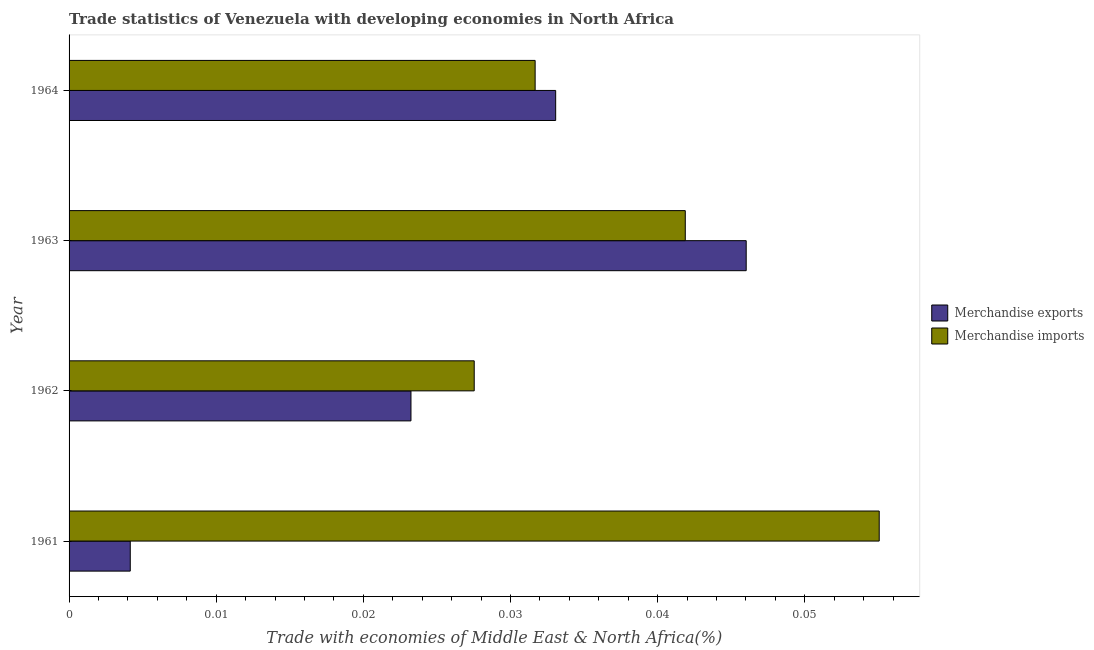How many groups of bars are there?
Make the answer very short. 4. Are the number of bars per tick equal to the number of legend labels?
Give a very brief answer. Yes. Are the number of bars on each tick of the Y-axis equal?
Your answer should be very brief. Yes. How many bars are there on the 2nd tick from the bottom?
Your answer should be very brief. 2. What is the label of the 2nd group of bars from the top?
Provide a short and direct response. 1963. What is the merchandise imports in 1963?
Ensure brevity in your answer.  0.04. Across all years, what is the maximum merchandise exports?
Ensure brevity in your answer.  0.05. Across all years, what is the minimum merchandise imports?
Your answer should be very brief. 0.03. In which year was the merchandise exports maximum?
Your response must be concise. 1963. What is the total merchandise imports in the graph?
Give a very brief answer. 0.16. What is the difference between the merchandise imports in 1962 and that in 1964?
Provide a succinct answer. -0. What is the difference between the merchandise exports in 1962 and the merchandise imports in 1961?
Make the answer very short. -0.03. What is the average merchandise imports per year?
Give a very brief answer. 0.04. In the year 1963, what is the difference between the merchandise imports and merchandise exports?
Your response must be concise. -0. In how many years, is the merchandise imports greater than 0.02 %?
Make the answer very short. 4. What is the ratio of the merchandise exports in 1961 to that in 1962?
Offer a terse response. 0.18. Is the merchandise imports in 1961 less than that in 1963?
Offer a terse response. No. Is the difference between the merchandise exports in 1962 and 1963 greater than the difference between the merchandise imports in 1962 and 1963?
Ensure brevity in your answer.  No. What is the difference between the highest and the second highest merchandise exports?
Your response must be concise. 0.01. In how many years, is the merchandise exports greater than the average merchandise exports taken over all years?
Make the answer very short. 2. How many bars are there?
Offer a terse response. 8. Are all the bars in the graph horizontal?
Offer a very short reply. Yes. Are the values on the major ticks of X-axis written in scientific E-notation?
Your answer should be compact. No. Does the graph contain any zero values?
Make the answer very short. No. How many legend labels are there?
Offer a terse response. 2. What is the title of the graph?
Provide a short and direct response. Trade statistics of Venezuela with developing economies in North Africa. Does "Resident" appear as one of the legend labels in the graph?
Your answer should be very brief. No. What is the label or title of the X-axis?
Your answer should be very brief. Trade with economies of Middle East & North Africa(%). What is the Trade with economies of Middle East & North Africa(%) in Merchandise exports in 1961?
Offer a very short reply. 0. What is the Trade with economies of Middle East & North Africa(%) of Merchandise imports in 1961?
Your response must be concise. 0.06. What is the Trade with economies of Middle East & North Africa(%) of Merchandise exports in 1962?
Provide a succinct answer. 0.02. What is the Trade with economies of Middle East & North Africa(%) in Merchandise imports in 1962?
Your answer should be very brief. 0.03. What is the Trade with economies of Middle East & North Africa(%) in Merchandise exports in 1963?
Keep it short and to the point. 0.05. What is the Trade with economies of Middle East & North Africa(%) of Merchandise imports in 1963?
Ensure brevity in your answer.  0.04. What is the Trade with economies of Middle East & North Africa(%) in Merchandise exports in 1964?
Make the answer very short. 0.03. What is the Trade with economies of Middle East & North Africa(%) in Merchandise imports in 1964?
Provide a succinct answer. 0.03. Across all years, what is the maximum Trade with economies of Middle East & North Africa(%) of Merchandise exports?
Your response must be concise. 0.05. Across all years, what is the maximum Trade with economies of Middle East & North Africa(%) of Merchandise imports?
Your response must be concise. 0.06. Across all years, what is the minimum Trade with economies of Middle East & North Africa(%) in Merchandise exports?
Make the answer very short. 0. Across all years, what is the minimum Trade with economies of Middle East & North Africa(%) in Merchandise imports?
Offer a very short reply. 0.03. What is the total Trade with economies of Middle East & North Africa(%) in Merchandise exports in the graph?
Your answer should be very brief. 0.11. What is the total Trade with economies of Middle East & North Africa(%) in Merchandise imports in the graph?
Give a very brief answer. 0.16. What is the difference between the Trade with economies of Middle East & North Africa(%) in Merchandise exports in 1961 and that in 1962?
Make the answer very short. -0.02. What is the difference between the Trade with economies of Middle East & North Africa(%) in Merchandise imports in 1961 and that in 1962?
Give a very brief answer. 0.03. What is the difference between the Trade with economies of Middle East & North Africa(%) of Merchandise exports in 1961 and that in 1963?
Your answer should be compact. -0.04. What is the difference between the Trade with economies of Middle East & North Africa(%) of Merchandise imports in 1961 and that in 1963?
Ensure brevity in your answer.  0.01. What is the difference between the Trade with economies of Middle East & North Africa(%) of Merchandise exports in 1961 and that in 1964?
Your answer should be compact. -0.03. What is the difference between the Trade with economies of Middle East & North Africa(%) of Merchandise imports in 1961 and that in 1964?
Your answer should be compact. 0.02. What is the difference between the Trade with economies of Middle East & North Africa(%) of Merchandise exports in 1962 and that in 1963?
Keep it short and to the point. -0.02. What is the difference between the Trade with economies of Middle East & North Africa(%) in Merchandise imports in 1962 and that in 1963?
Make the answer very short. -0.01. What is the difference between the Trade with economies of Middle East & North Africa(%) of Merchandise exports in 1962 and that in 1964?
Keep it short and to the point. -0.01. What is the difference between the Trade with economies of Middle East & North Africa(%) in Merchandise imports in 1962 and that in 1964?
Ensure brevity in your answer.  -0. What is the difference between the Trade with economies of Middle East & North Africa(%) of Merchandise exports in 1963 and that in 1964?
Ensure brevity in your answer.  0.01. What is the difference between the Trade with economies of Middle East & North Africa(%) in Merchandise imports in 1963 and that in 1964?
Provide a short and direct response. 0.01. What is the difference between the Trade with economies of Middle East & North Africa(%) of Merchandise exports in 1961 and the Trade with economies of Middle East & North Africa(%) of Merchandise imports in 1962?
Give a very brief answer. -0.02. What is the difference between the Trade with economies of Middle East & North Africa(%) in Merchandise exports in 1961 and the Trade with economies of Middle East & North Africa(%) in Merchandise imports in 1963?
Your answer should be compact. -0.04. What is the difference between the Trade with economies of Middle East & North Africa(%) in Merchandise exports in 1961 and the Trade with economies of Middle East & North Africa(%) in Merchandise imports in 1964?
Provide a short and direct response. -0.03. What is the difference between the Trade with economies of Middle East & North Africa(%) in Merchandise exports in 1962 and the Trade with economies of Middle East & North Africa(%) in Merchandise imports in 1963?
Provide a succinct answer. -0.02. What is the difference between the Trade with economies of Middle East & North Africa(%) in Merchandise exports in 1962 and the Trade with economies of Middle East & North Africa(%) in Merchandise imports in 1964?
Your answer should be compact. -0.01. What is the difference between the Trade with economies of Middle East & North Africa(%) of Merchandise exports in 1963 and the Trade with economies of Middle East & North Africa(%) of Merchandise imports in 1964?
Provide a short and direct response. 0.01. What is the average Trade with economies of Middle East & North Africa(%) in Merchandise exports per year?
Ensure brevity in your answer.  0.03. What is the average Trade with economies of Middle East & North Africa(%) in Merchandise imports per year?
Offer a terse response. 0.04. In the year 1961, what is the difference between the Trade with economies of Middle East & North Africa(%) of Merchandise exports and Trade with economies of Middle East & North Africa(%) of Merchandise imports?
Provide a succinct answer. -0.05. In the year 1962, what is the difference between the Trade with economies of Middle East & North Africa(%) of Merchandise exports and Trade with economies of Middle East & North Africa(%) of Merchandise imports?
Ensure brevity in your answer.  -0. In the year 1963, what is the difference between the Trade with economies of Middle East & North Africa(%) of Merchandise exports and Trade with economies of Middle East & North Africa(%) of Merchandise imports?
Provide a short and direct response. 0. In the year 1964, what is the difference between the Trade with economies of Middle East & North Africa(%) of Merchandise exports and Trade with economies of Middle East & North Africa(%) of Merchandise imports?
Your answer should be compact. 0. What is the ratio of the Trade with economies of Middle East & North Africa(%) of Merchandise exports in 1961 to that in 1962?
Provide a succinct answer. 0.18. What is the ratio of the Trade with economies of Middle East & North Africa(%) of Merchandise imports in 1961 to that in 1962?
Provide a short and direct response. 2. What is the ratio of the Trade with economies of Middle East & North Africa(%) of Merchandise exports in 1961 to that in 1963?
Provide a succinct answer. 0.09. What is the ratio of the Trade with economies of Middle East & North Africa(%) of Merchandise imports in 1961 to that in 1963?
Ensure brevity in your answer.  1.31. What is the ratio of the Trade with economies of Middle East & North Africa(%) in Merchandise exports in 1961 to that in 1964?
Offer a terse response. 0.13. What is the ratio of the Trade with economies of Middle East & North Africa(%) in Merchandise imports in 1961 to that in 1964?
Your response must be concise. 1.74. What is the ratio of the Trade with economies of Middle East & North Africa(%) of Merchandise exports in 1962 to that in 1963?
Your response must be concise. 0.5. What is the ratio of the Trade with economies of Middle East & North Africa(%) in Merchandise imports in 1962 to that in 1963?
Offer a terse response. 0.66. What is the ratio of the Trade with economies of Middle East & North Africa(%) of Merchandise exports in 1962 to that in 1964?
Provide a succinct answer. 0.7. What is the ratio of the Trade with economies of Middle East & North Africa(%) in Merchandise imports in 1962 to that in 1964?
Provide a short and direct response. 0.87. What is the ratio of the Trade with economies of Middle East & North Africa(%) of Merchandise exports in 1963 to that in 1964?
Provide a succinct answer. 1.39. What is the ratio of the Trade with economies of Middle East & North Africa(%) of Merchandise imports in 1963 to that in 1964?
Your answer should be very brief. 1.32. What is the difference between the highest and the second highest Trade with economies of Middle East & North Africa(%) in Merchandise exports?
Your answer should be very brief. 0.01. What is the difference between the highest and the second highest Trade with economies of Middle East & North Africa(%) of Merchandise imports?
Your response must be concise. 0.01. What is the difference between the highest and the lowest Trade with economies of Middle East & North Africa(%) in Merchandise exports?
Keep it short and to the point. 0.04. What is the difference between the highest and the lowest Trade with economies of Middle East & North Africa(%) in Merchandise imports?
Keep it short and to the point. 0.03. 